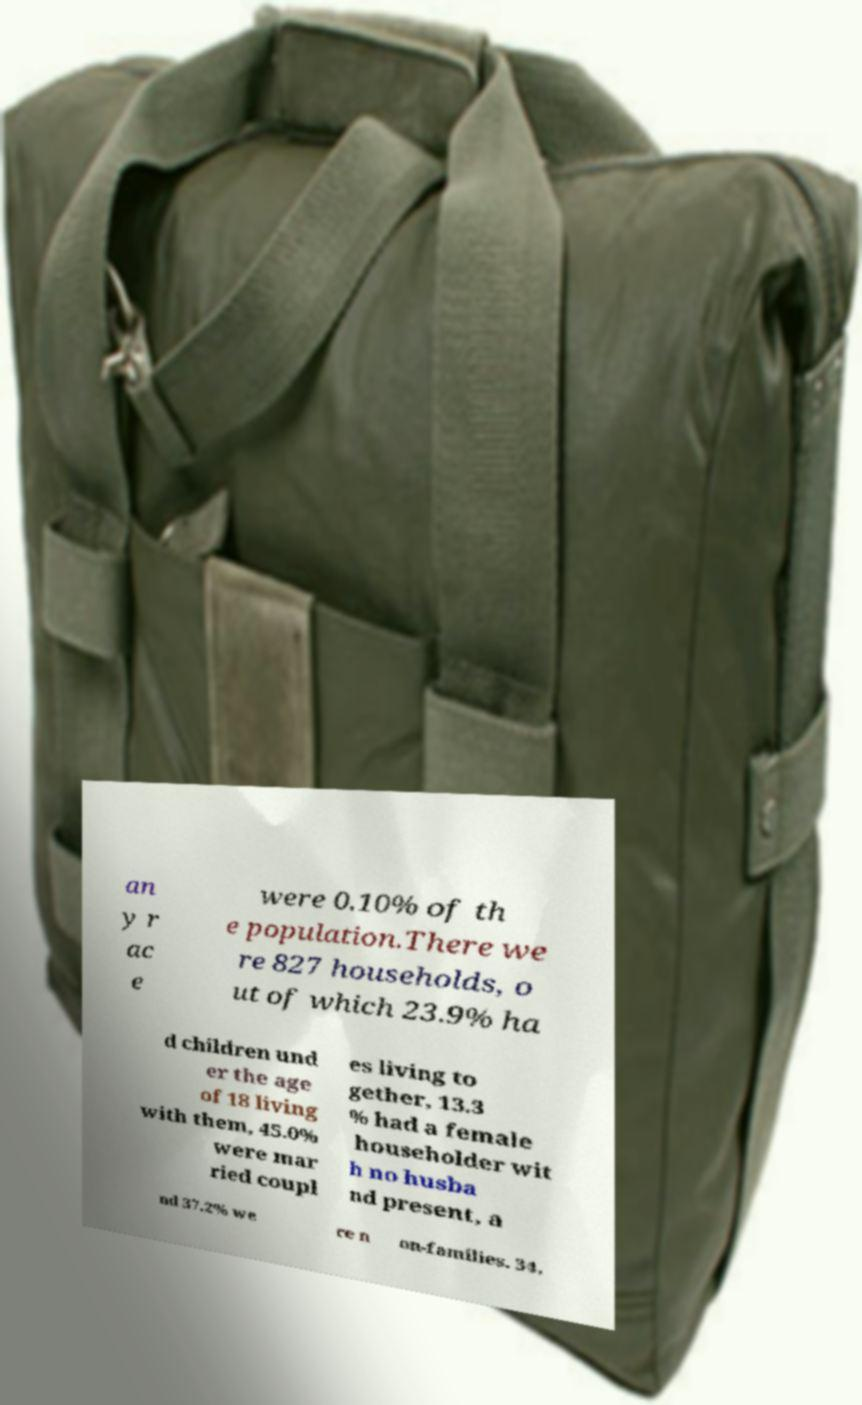Could you assist in decoding the text presented in this image and type it out clearly? an y r ac e were 0.10% of th e population.There we re 827 households, o ut of which 23.9% ha d children und er the age of 18 living with them, 45.0% were mar ried coupl es living to gether, 13.3 % had a female householder wit h no husba nd present, a nd 37.2% we re n on-families. 34. 